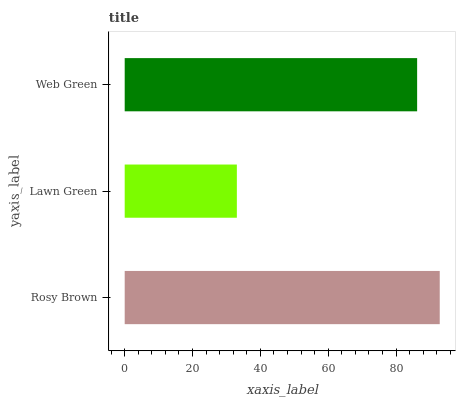Is Lawn Green the minimum?
Answer yes or no. Yes. Is Rosy Brown the maximum?
Answer yes or no. Yes. Is Web Green the minimum?
Answer yes or no. No. Is Web Green the maximum?
Answer yes or no. No. Is Web Green greater than Lawn Green?
Answer yes or no. Yes. Is Lawn Green less than Web Green?
Answer yes or no. Yes. Is Lawn Green greater than Web Green?
Answer yes or no. No. Is Web Green less than Lawn Green?
Answer yes or no. No. Is Web Green the high median?
Answer yes or no. Yes. Is Web Green the low median?
Answer yes or no. Yes. Is Lawn Green the high median?
Answer yes or no. No. Is Lawn Green the low median?
Answer yes or no. No. 